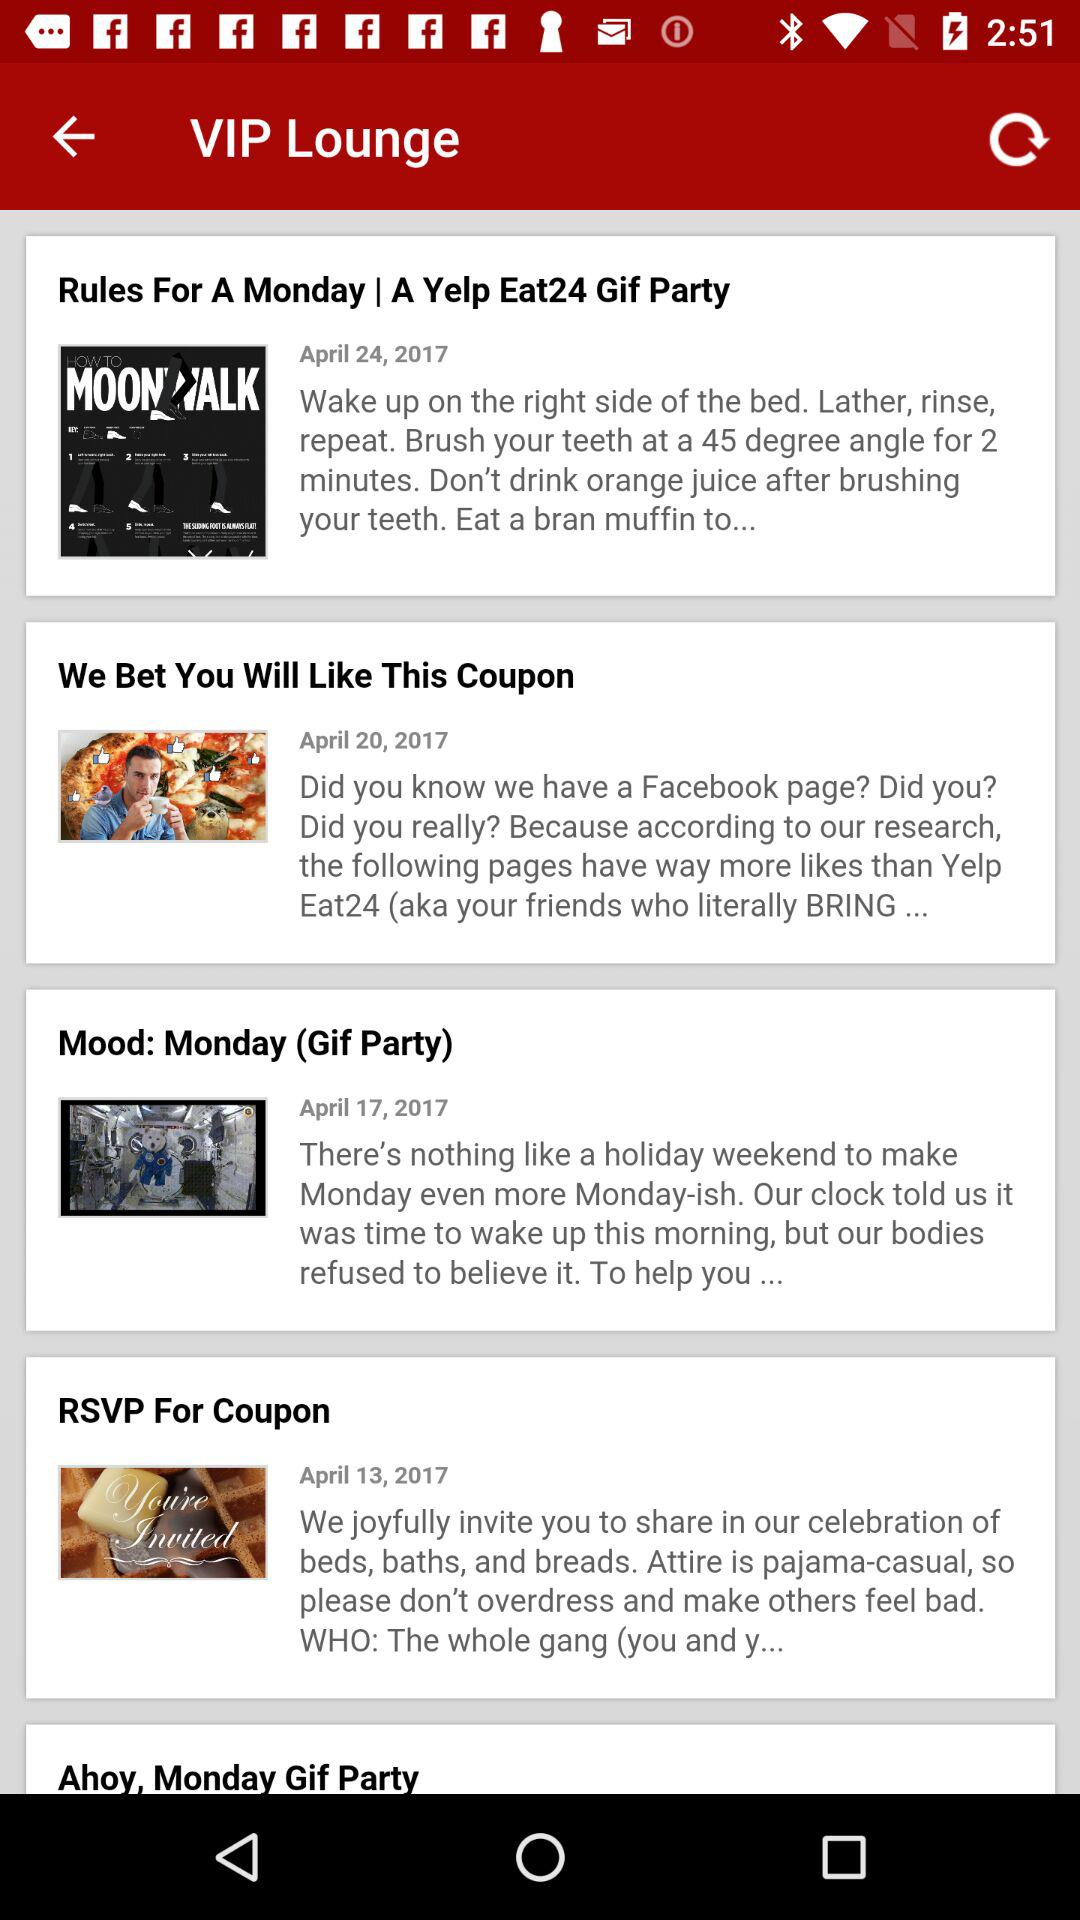How many items were created in April?
Answer the question using a single word or phrase. 4 